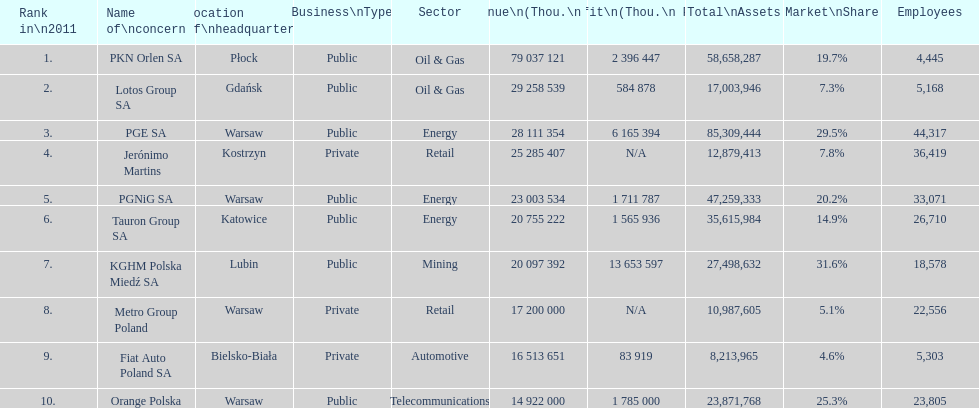Which company had the most revenue? PKN Orlen SA. 